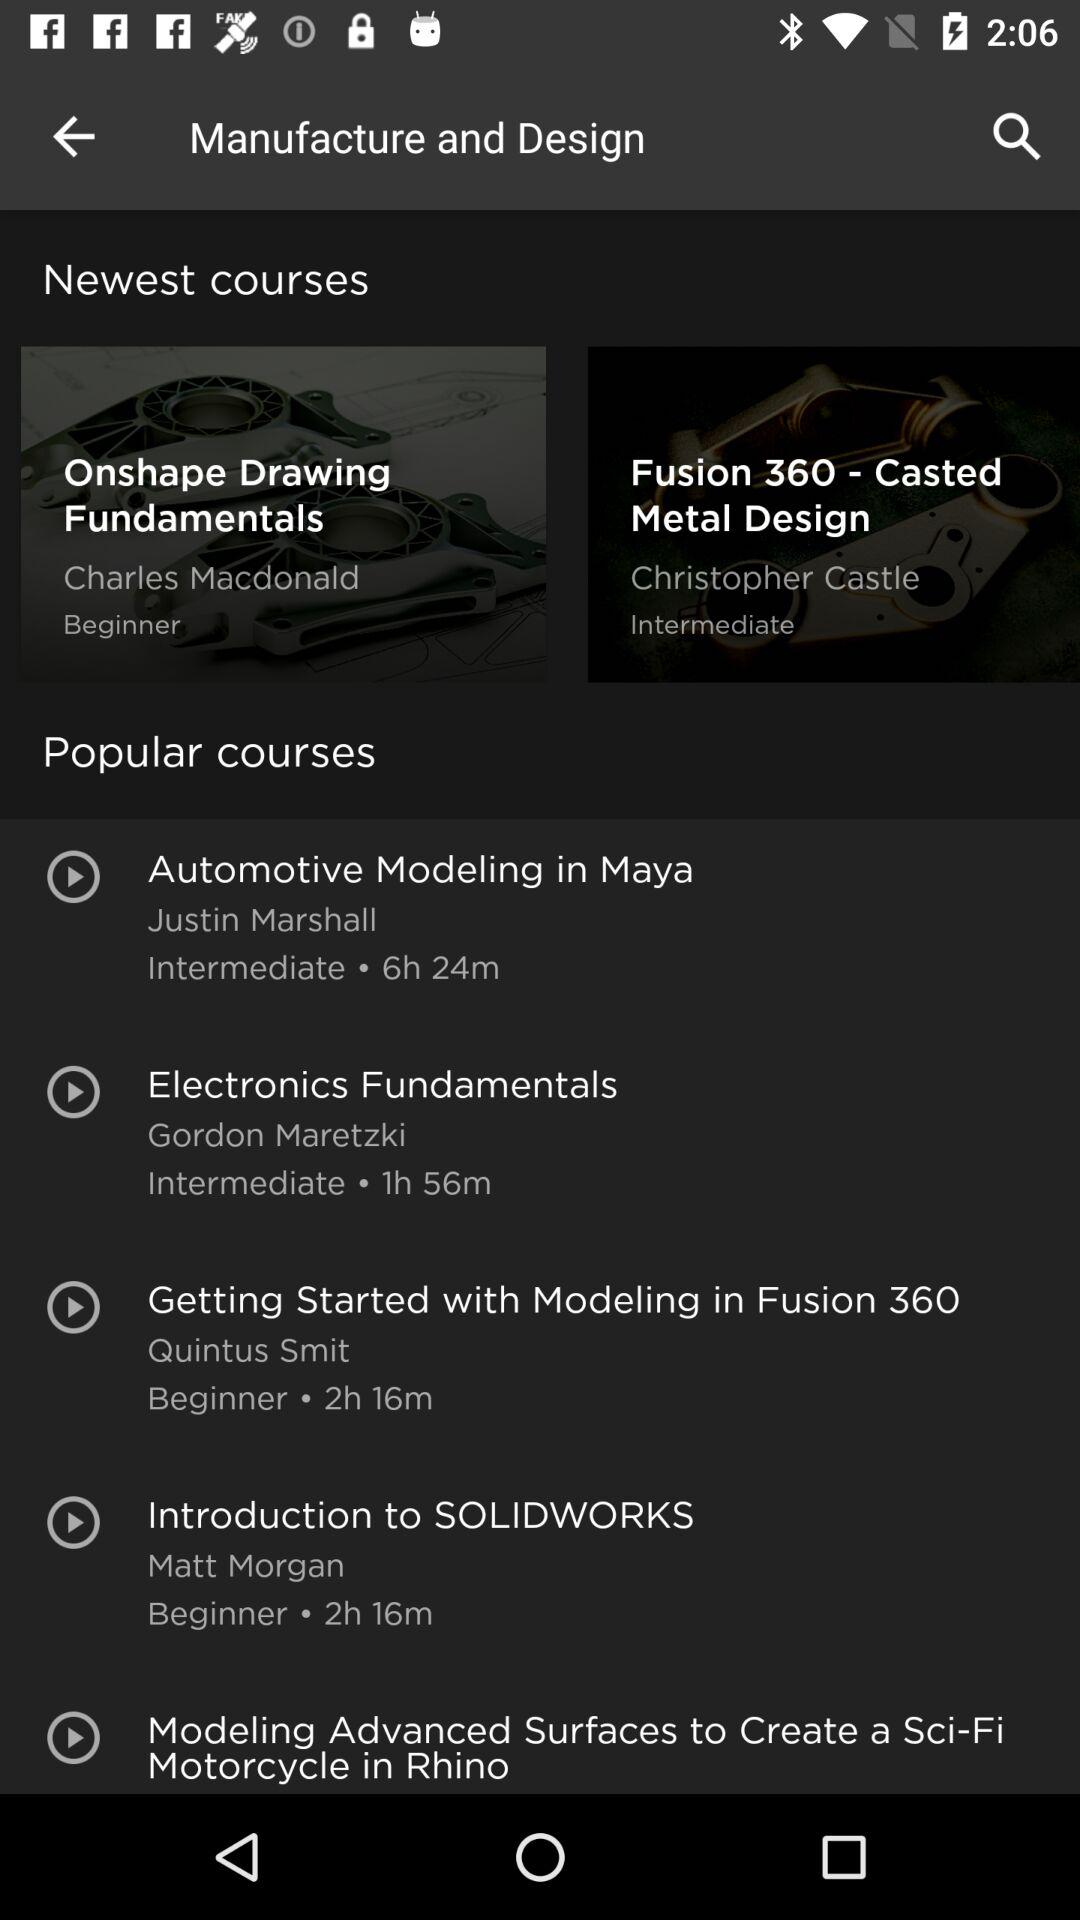How many courses are in the Popular courses section?
Answer the question using a single word or phrase. 5 